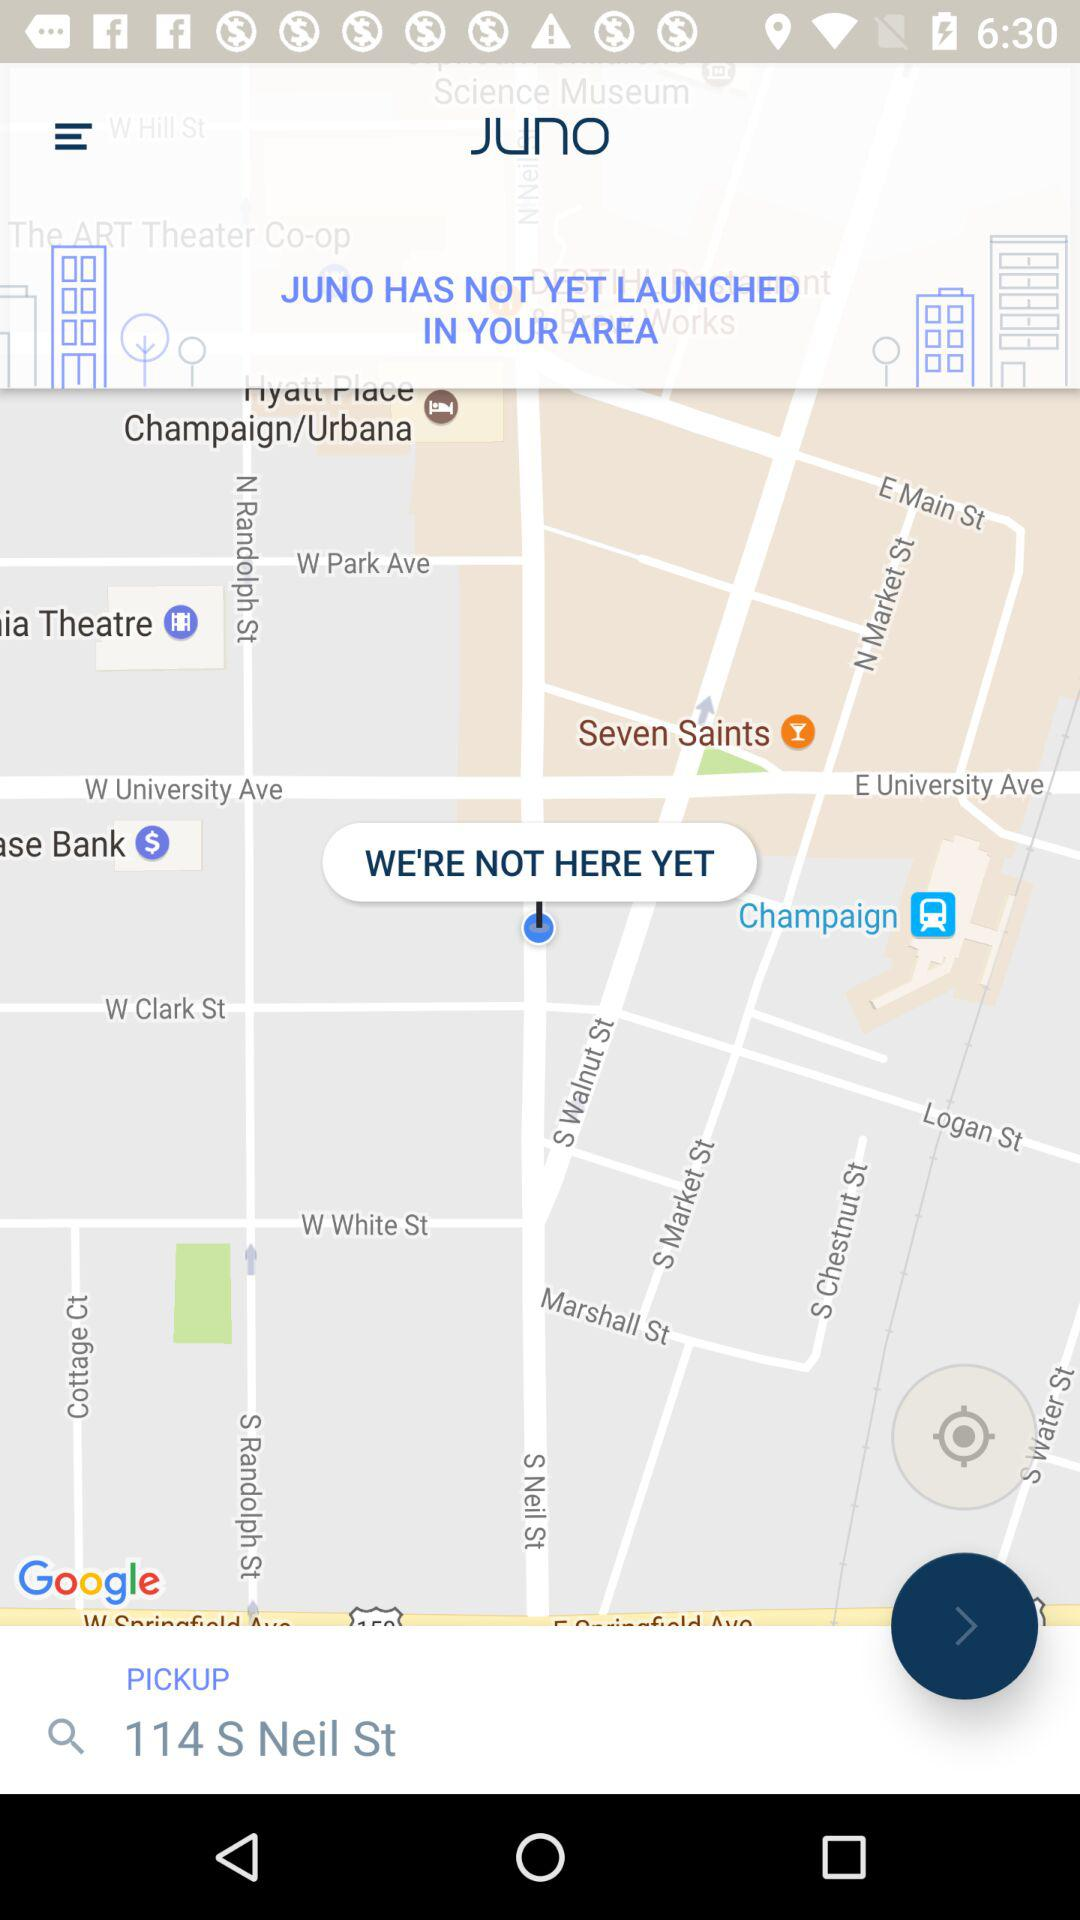What is the app name? The app name is "Juno". 